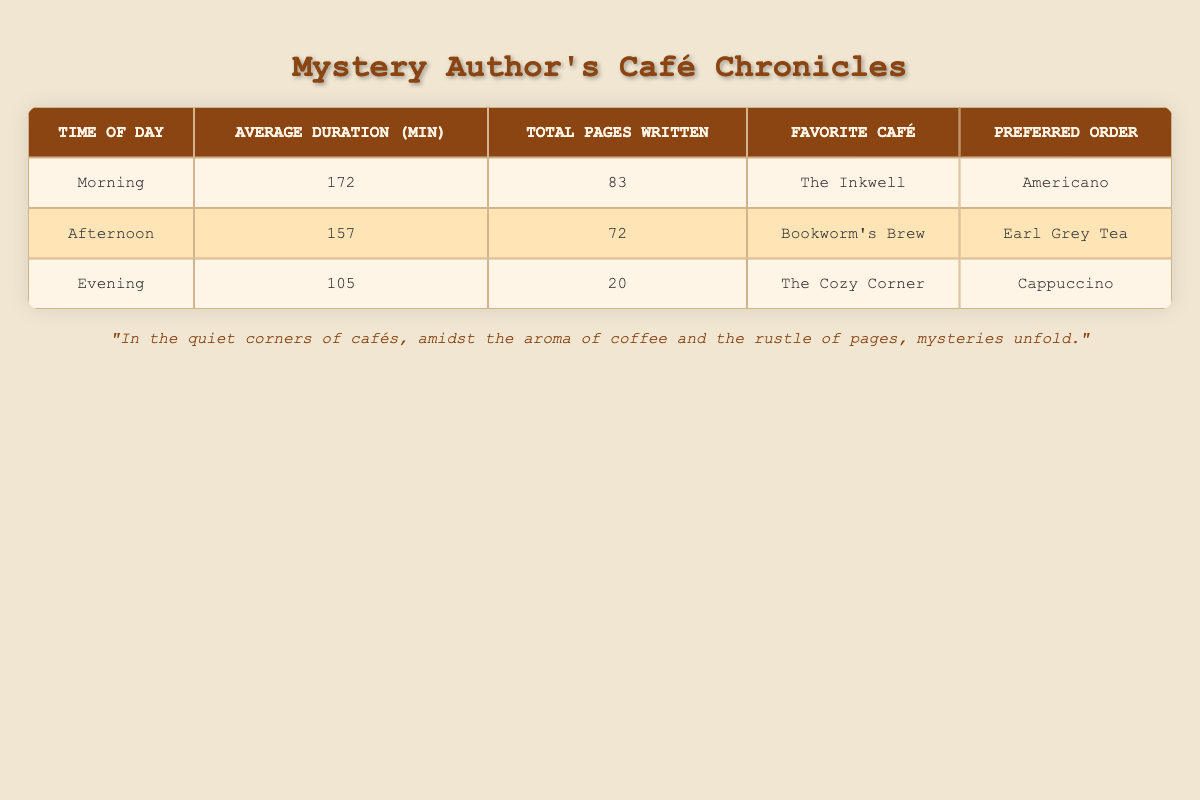What is the average duration of visits in the Morning? The average duration for the Morning visits is calculated by adding up the durations for each visit during this time. The values are 120, 150, and 240 minutes. Summing these gives 120 + 150 + 240 = 510. There are three visits, so the average is 510 / 3 = 170 minutes.
Answer: 170 Which café is the favorite for Afternoon visits? According to the table, the café listed for Afternoon visits is Bookworm's Brew. This is the only café mentioned for this time slot, so it can be identified as the favorite.
Answer: Bookworm's Brew Does the Evening have the lowest average duration among all time slots? To determine if Evening has the lowest average duration, we need to compare it with the average durations for Morning (172 minutes) and Afternoon (157 minutes). The average duration for Evening is 105 minutes. Since 105 is less than both 172 and 157, it confirms that Evening has the lowest.
Answer: Yes How many total pages were written during Afternoon visits? The total pages written for Afternoon visits can be found by adding the pages from both Emily Blackwood's and Michael Connelly's visits, which are 22 and 10 pages. Adding these gives 22 + 10 = 32 pages.
Answer: 32 What is the difference in total pages written between Morning and Afternoon visits? First, we need to calculate the total pages for each time slot. Morning totals 83 pages, and Afternoon totals 72 pages. The difference can be calculated by subtracting the Afternoon total from the Morning total: 83 - 72 = 11 pages.
Answer: 11 Which time of day had the highest total pages written? By examining the total pages written for each time of day, we see that Morning had 83 pages, Afternoon had 72 pages, and Evening had 20 pages. Therefore, since 83 is greater than both 72 and 20, Morning had the highest total pages written.
Answer: Morning Is Earl Grey Tea the most ordered item across all times of day? The most ordered items listed in each time slot are Americano for Morning, Earl Grey Tea for Afternoon, and Cappuccino for Evening. Since there are only three times of day and Earl Grey Tea is mentioned for just one of them, it cannot be the most ordered item.
Answer: No How many total visits were recorded in the Evening? The number of visits during the Evening can be found by counting the entries for that time across all visitors. In the table, there's only one entry for Evening. Therefore, the total number of visits recorded in the Evening is 1.
Answer: 1 